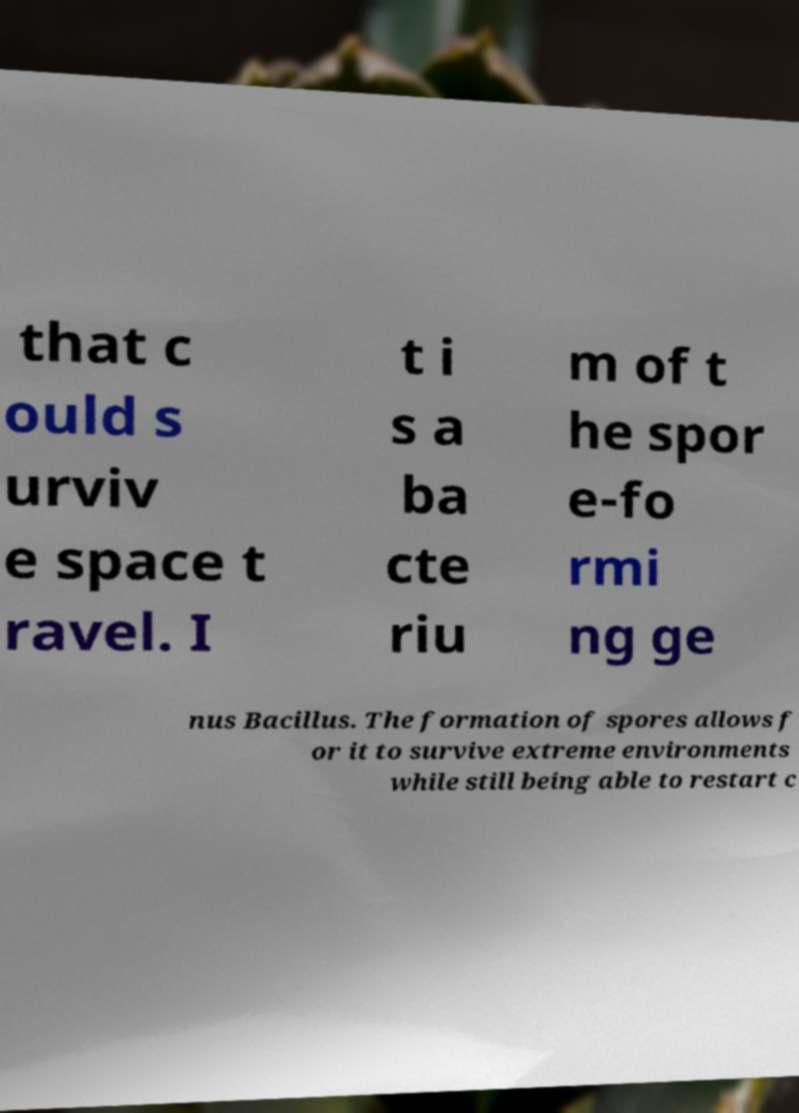Please identify and transcribe the text found in this image. that c ould s urviv e space t ravel. I t i s a ba cte riu m of t he spor e-fo rmi ng ge nus Bacillus. The formation of spores allows f or it to survive extreme environments while still being able to restart c 